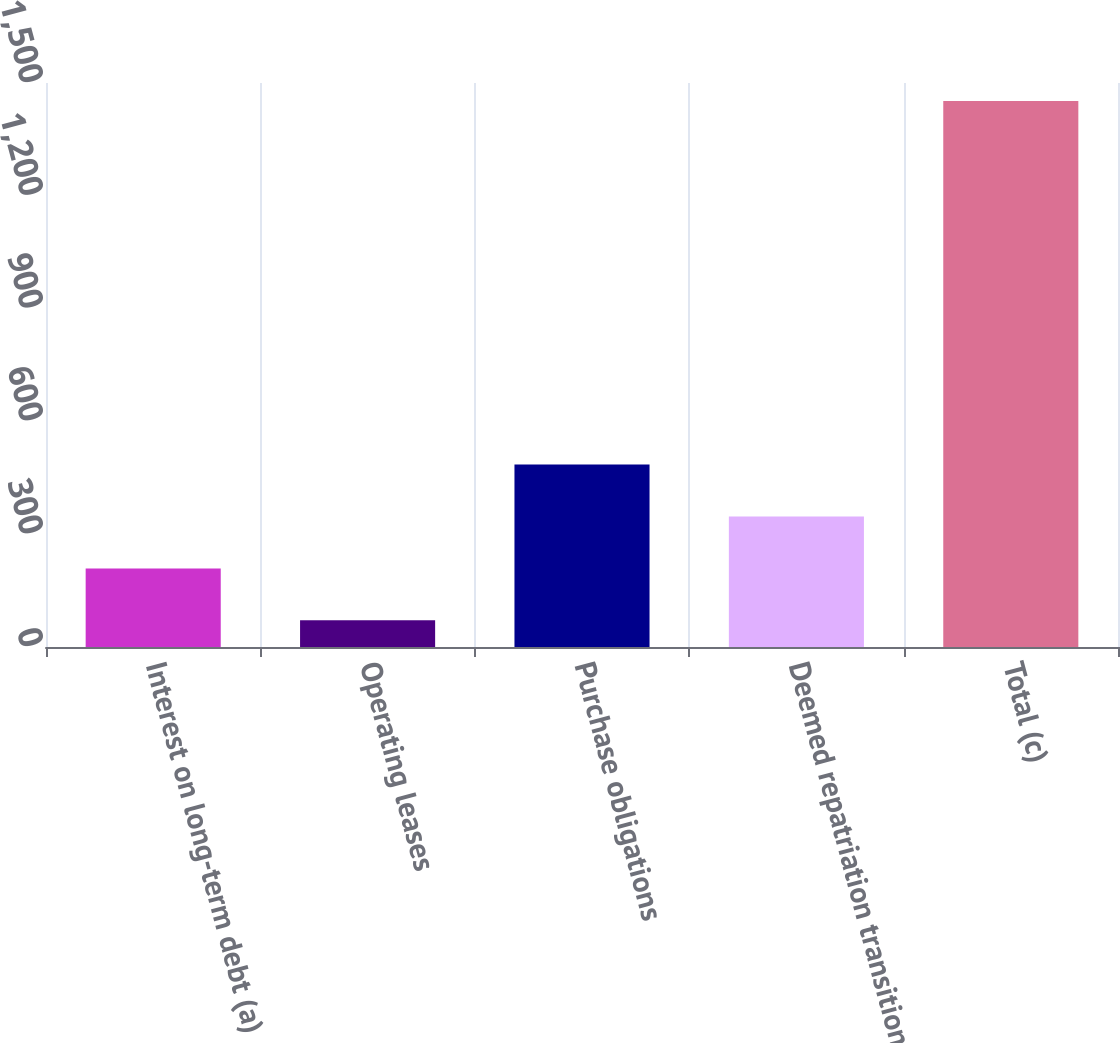Convert chart to OTSL. <chart><loc_0><loc_0><loc_500><loc_500><bar_chart><fcel>Interest on long-term debt (a)<fcel>Operating leases<fcel>Purchase obligations<fcel>Deemed repatriation transition<fcel>Total (c)<nl><fcel>209.1<fcel>71<fcel>485.3<fcel>347.2<fcel>1452<nl></chart> 